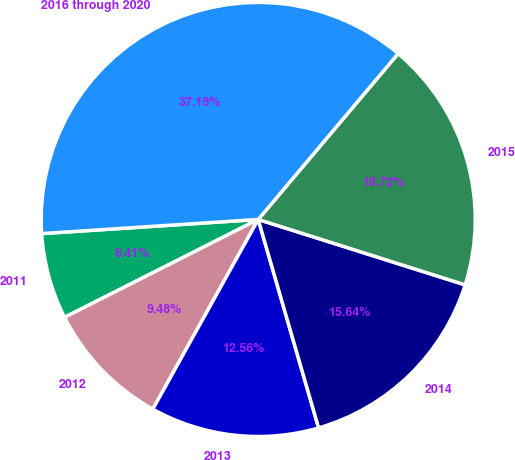Convert chart to OTSL. <chart><loc_0><loc_0><loc_500><loc_500><pie_chart><fcel>2011<fcel>2012<fcel>2013<fcel>2014<fcel>2015<fcel>2016 through 2020<nl><fcel>6.41%<fcel>9.48%<fcel>12.56%<fcel>15.64%<fcel>18.72%<fcel>37.19%<nl></chart> 